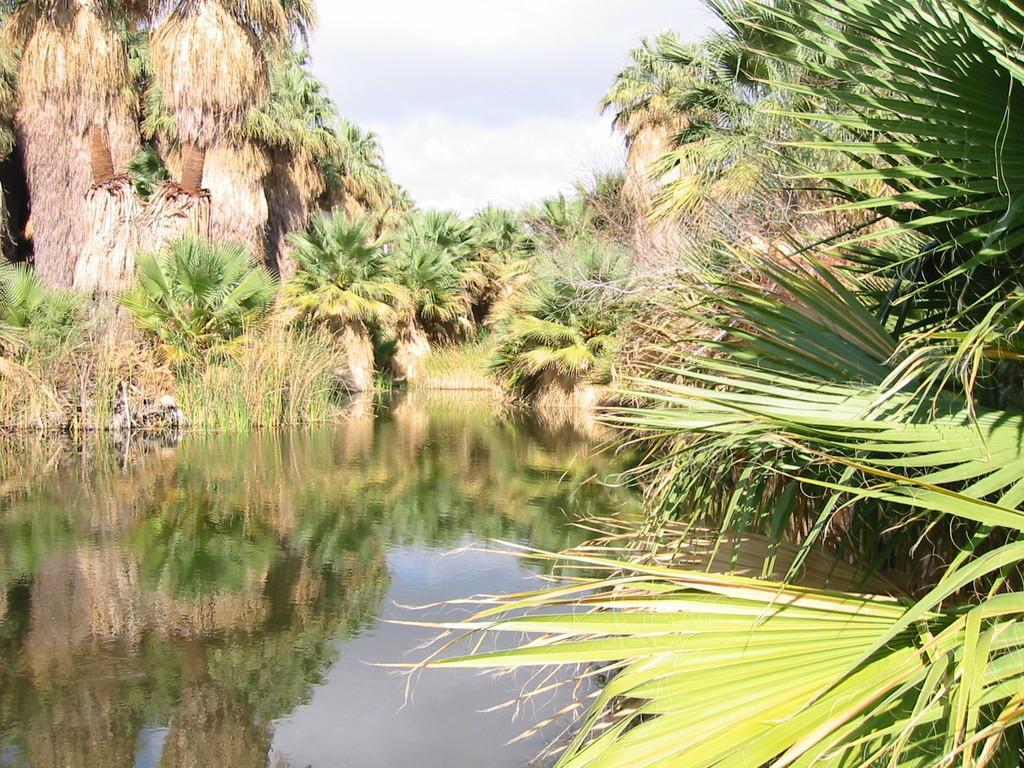Please provide a concise description of this image. This image consists of many trees and plants. At the bottom, there is water. At the top, there are clouds in the sky. 